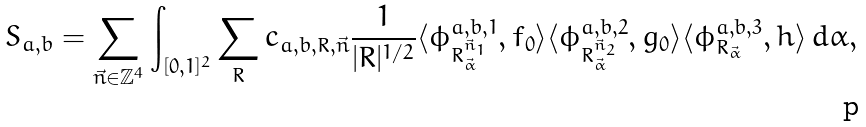Convert formula to latex. <formula><loc_0><loc_0><loc_500><loc_500>S _ { a , b } = \sum _ { \vec { n } \in \mathbb { Z } ^ { 4 } } \int _ { [ 0 , 1 ] ^ { 2 } } \sum _ { R } c _ { a , b , R , \vec { n } } \frac { 1 } { | R | ^ { 1 / 2 } } \langle \phi _ { R ^ { \vec { n } _ { 1 } } _ { \vec { \alpha } } } ^ { a , b , 1 } , f _ { 0 } \rangle \langle \phi _ { R ^ { \vec { n } _ { 2 } } _ { \vec { \alpha } } } ^ { a , b , 2 } , g _ { 0 } \rangle \langle \phi _ { R _ { \vec { \alpha } } } ^ { a , b , 3 } , h \rangle \, d \alpha ,</formula> 